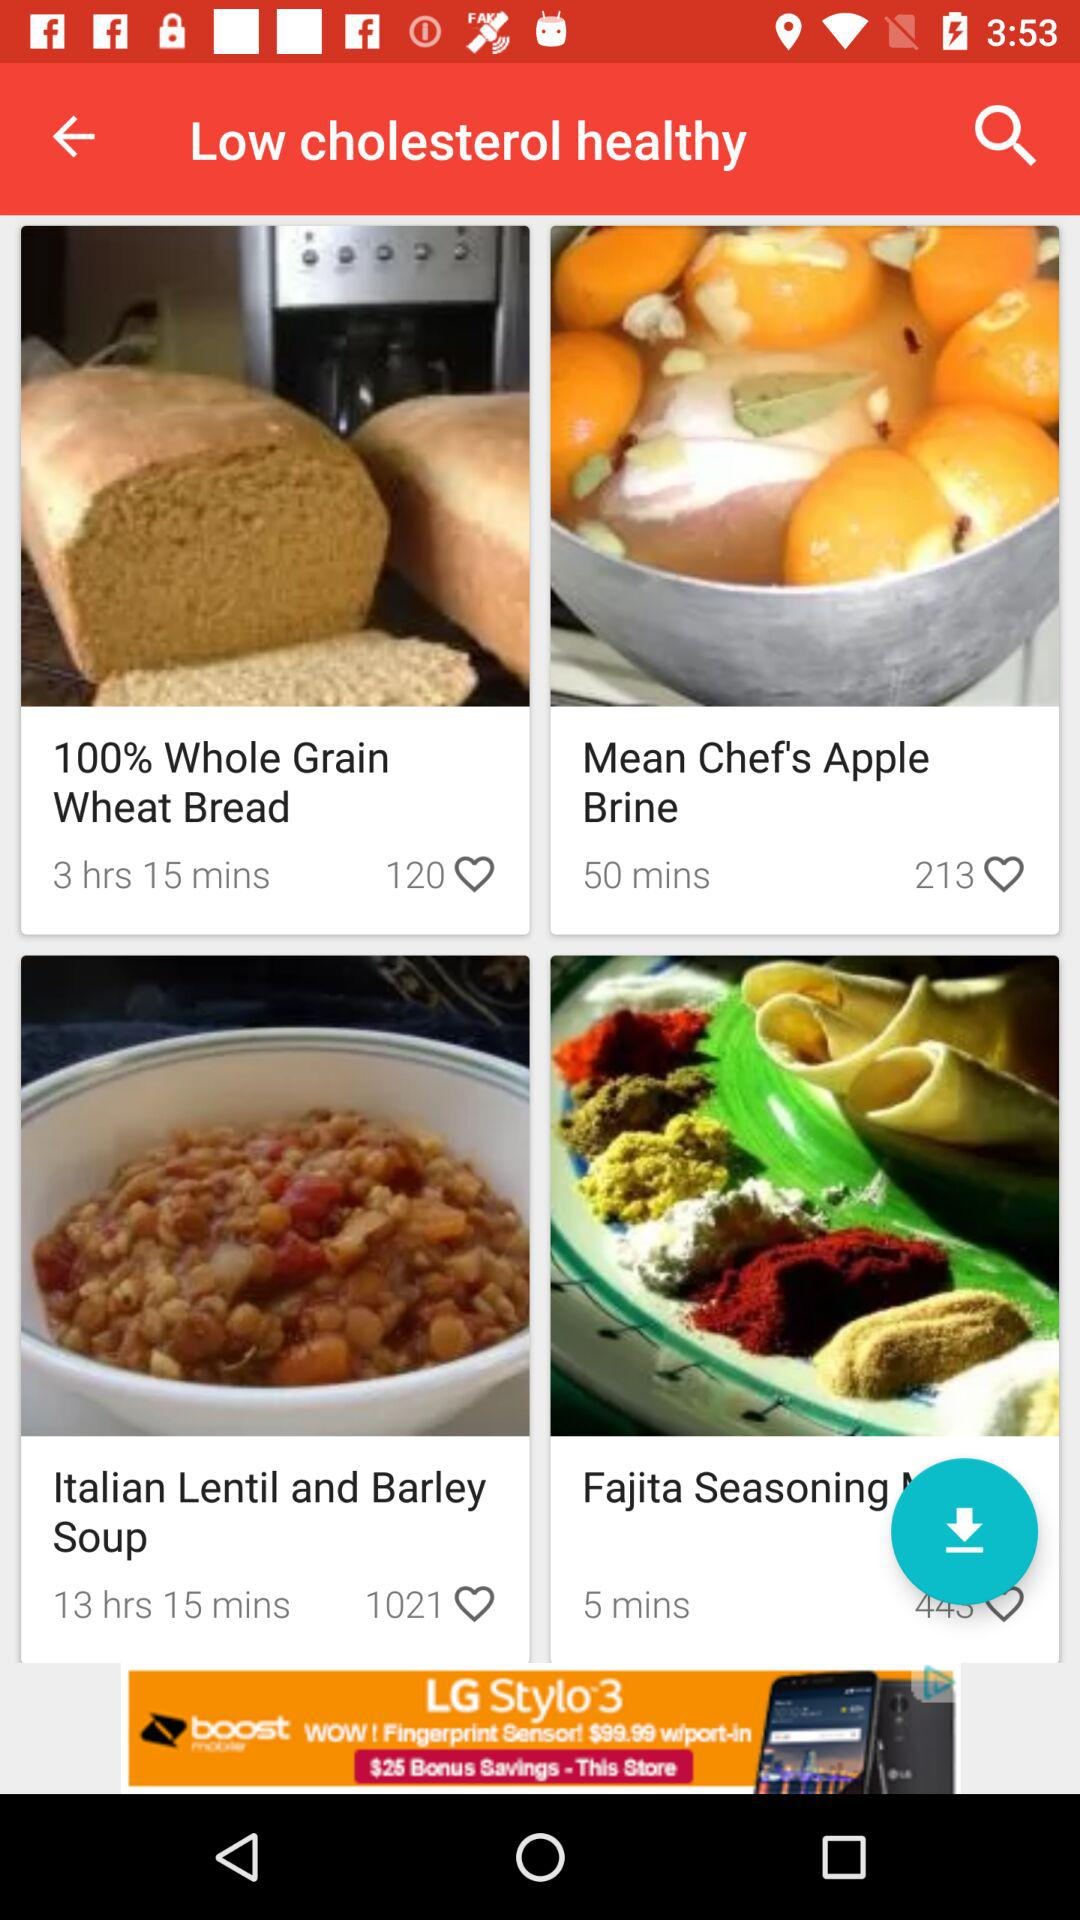What is the duration given for "Italian lentil"? The duration given for "Italian lentil" is 13 hours and 15 minutes. 